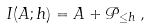Convert formula to latex. <formula><loc_0><loc_0><loc_500><loc_500>I ( A ; h ) = A + \mathcal { P } _ { \leq h } \, ,</formula> 